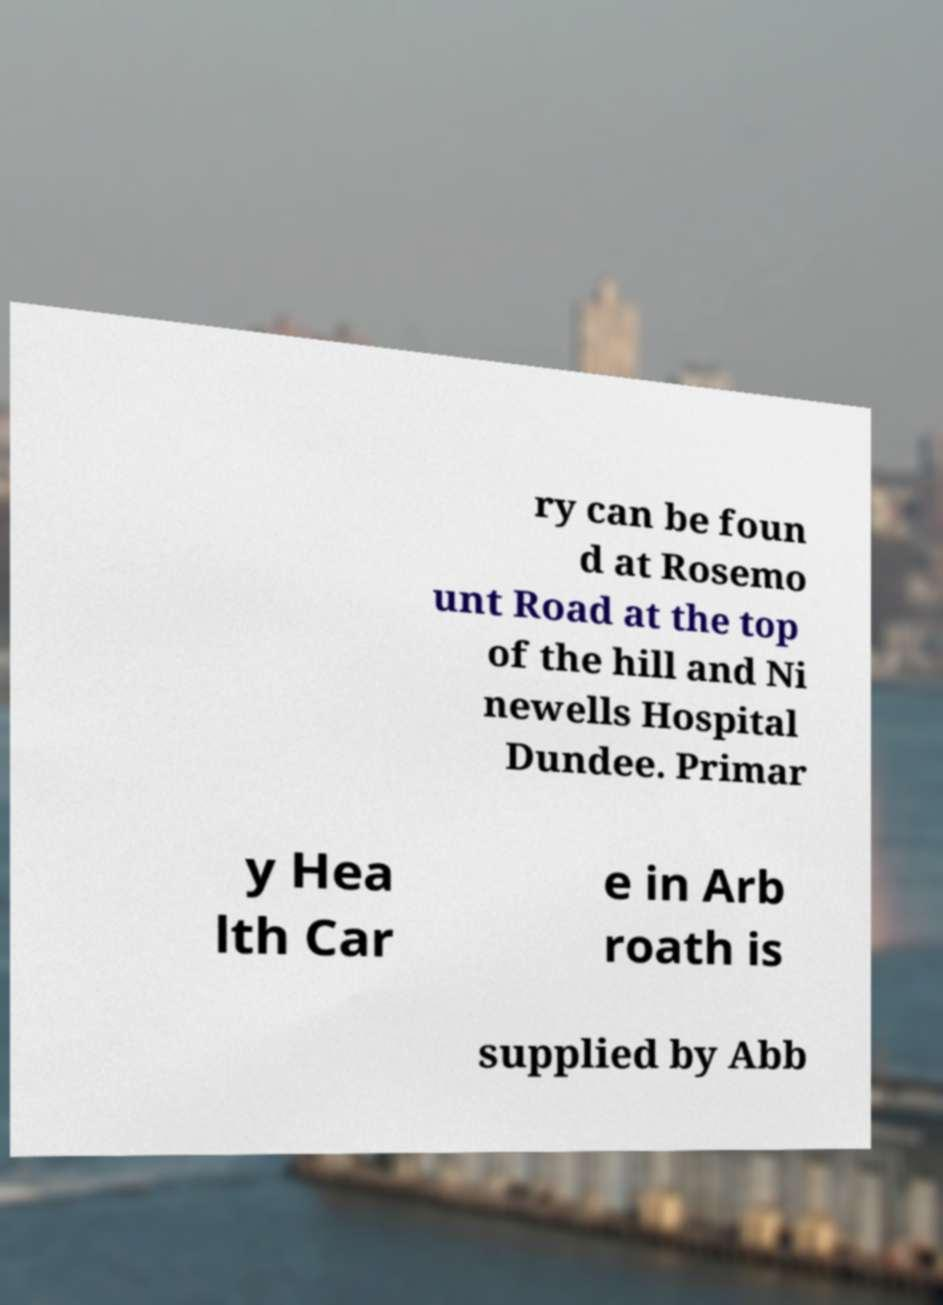There's text embedded in this image that I need extracted. Can you transcribe it verbatim? ry can be foun d at Rosemo unt Road at the top of the hill and Ni newells Hospital Dundee. Primar y Hea lth Car e in Arb roath is supplied by Abb 